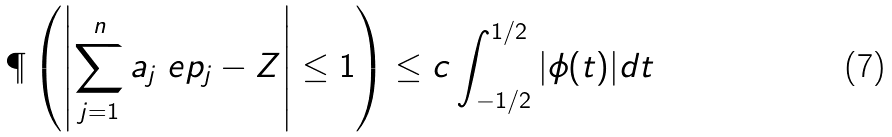<formula> <loc_0><loc_0><loc_500><loc_500>\P \left ( \left | \sum _ { j = 1 } ^ { n } a _ { j } \ e p _ { j } - Z \right | \leq 1 \right ) \leq c \int _ { - 1 / 2 } ^ { 1 / 2 } | \phi ( t ) | d t</formula> 